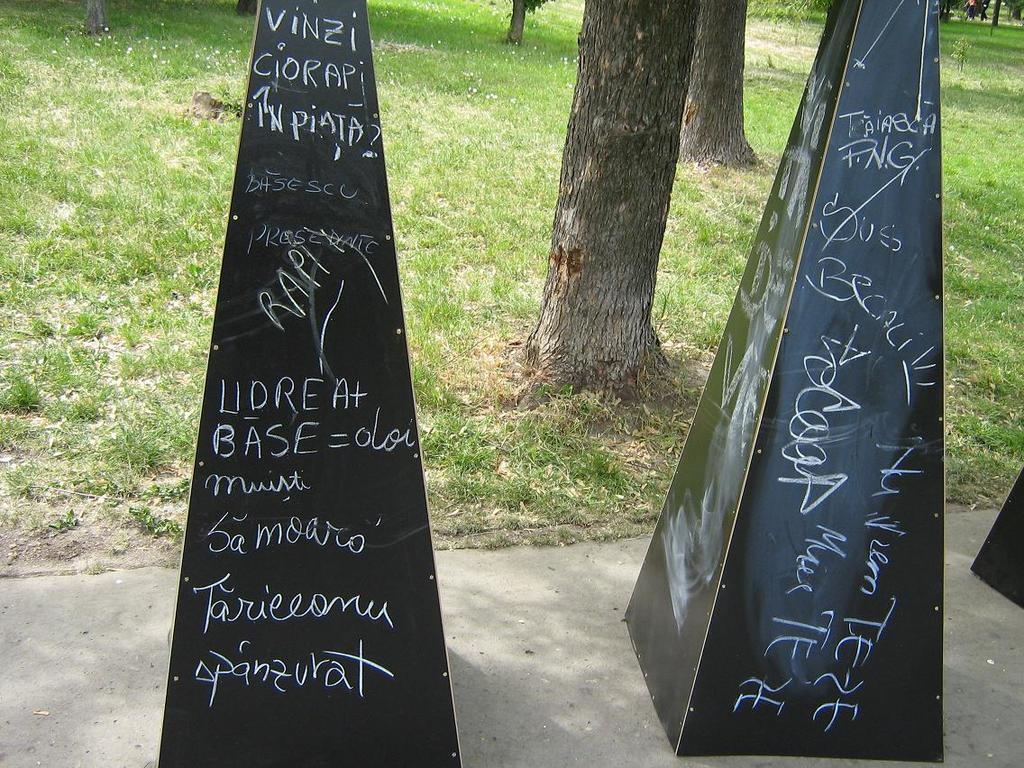What objects are on the floor in the image? There are inverted cones on the floor in the image. What is written on the cones? There is text written on the cones. What can be seen in the background of the image? There is a grassland visible in the background of the image. What type of vegetation is present in the grassland? There are trees in the grassland. Who is celebrating their birthday in the image? There is no indication of a birthday celebration in the image. Can you see the aunt of the person in the image? There is no person present in the image, so it is impossible to identify any relatives. 